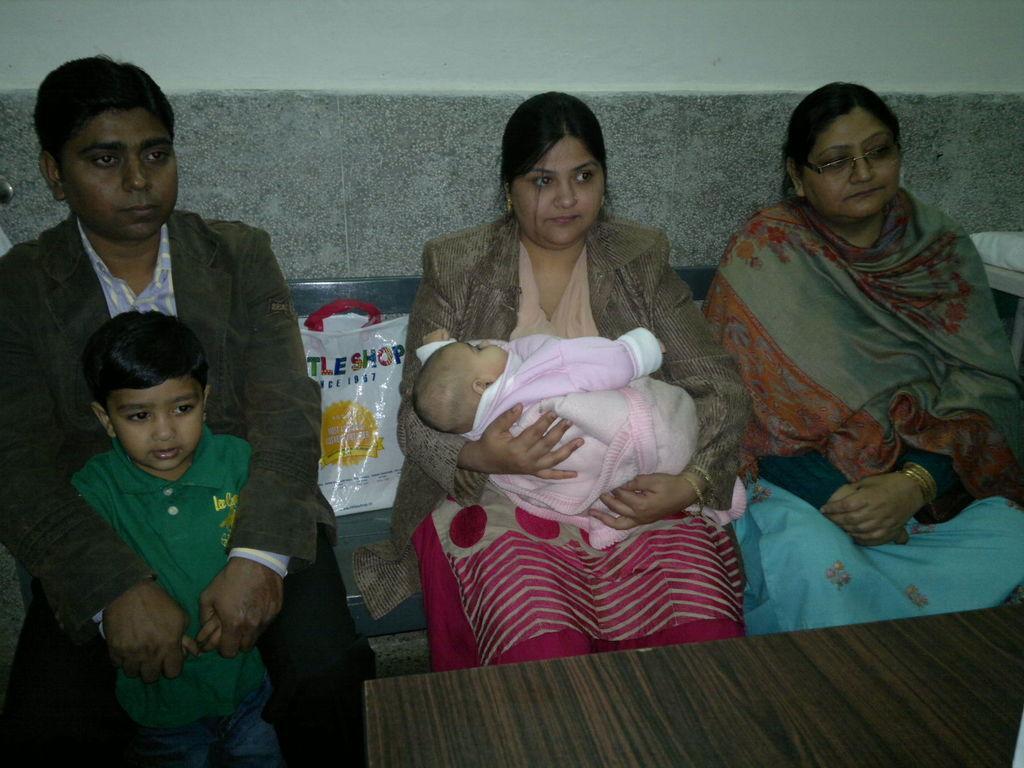In one or two sentences, can you explain what this image depicts? In this picture we can see two women and a man sitting on the bench and holding the baby in the hand. In the front bottom we can see the center table. Behind there is a white cover and grey cladding tiles on the white wall. 